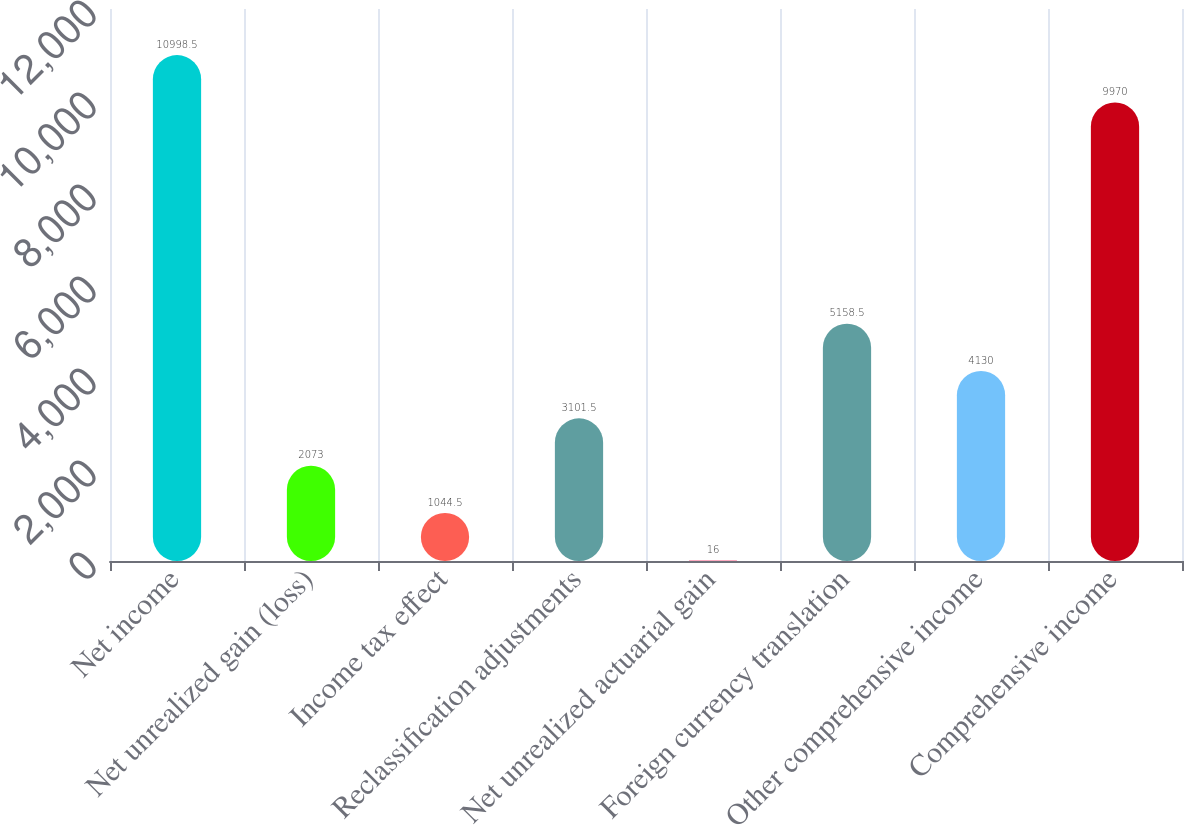<chart> <loc_0><loc_0><loc_500><loc_500><bar_chart><fcel>Net income<fcel>Net unrealized gain (loss)<fcel>Income tax effect<fcel>Reclassification adjustments<fcel>Net unrealized actuarial gain<fcel>Foreign currency translation<fcel>Other comprehensive income<fcel>Comprehensive income<nl><fcel>10998.5<fcel>2073<fcel>1044.5<fcel>3101.5<fcel>16<fcel>5158.5<fcel>4130<fcel>9970<nl></chart> 